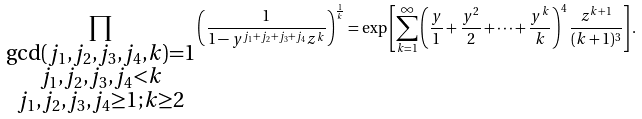Convert formula to latex. <formula><loc_0><loc_0><loc_500><loc_500>\prod _ { \substack { \gcd ( j _ { 1 } , j _ { 2 } , j _ { 3 } , j _ { 4 } , k ) = 1 \\ j _ { 1 } , j _ { 2 } , j _ { 3 } , j _ { 4 } < k \\ j _ { 1 } , j _ { 2 } , j _ { 3 } , j _ { 4 } \geq 1 ; k \geq 2 } } \left ( \frac { 1 } { 1 - y ^ { j _ { 1 } + j _ { 2 } + j _ { 3 } + j _ { 4 } } z ^ { k } } \right ) ^ { \frac { 1 } { k } } = \exp \left [ \sum _ { k = 1 } ^ { \infty } \left ( \frac { y } { 1 } + \frac { y ^ { 2 } } { 2 } + \cdots + \frac { y ^ { k } } { k } \right ) ^ { 4 } \frac { z ^ { k + 1 } } { ( k + 1 ) ^ { 3 } } \right ] .</formula> 